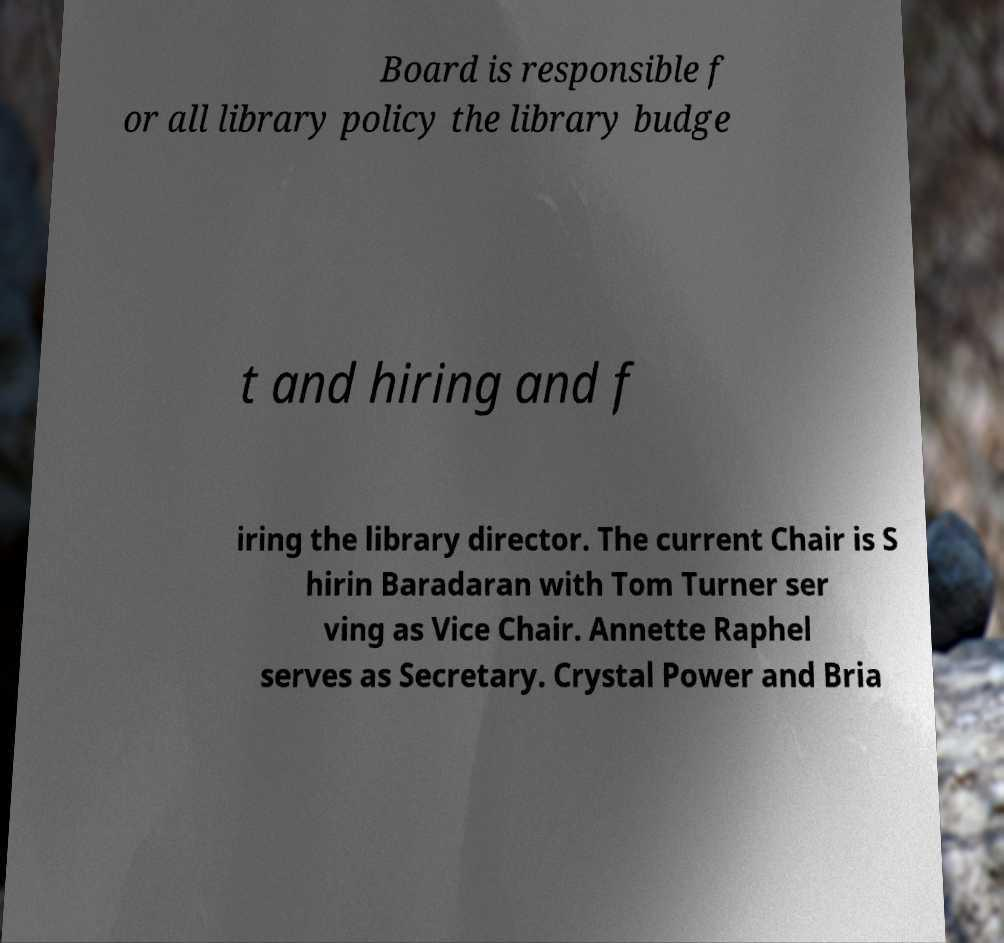Please read and relay the text visible in this image. What does it say? Board is responsible f or all library policy the library budge t and hiring and f iring the library director. The current Chair is S hirin Baradaran with Tom Turner ser ving as Vice Chair. Annette Raphel serves as Secretary. Crystal Power and Bria 